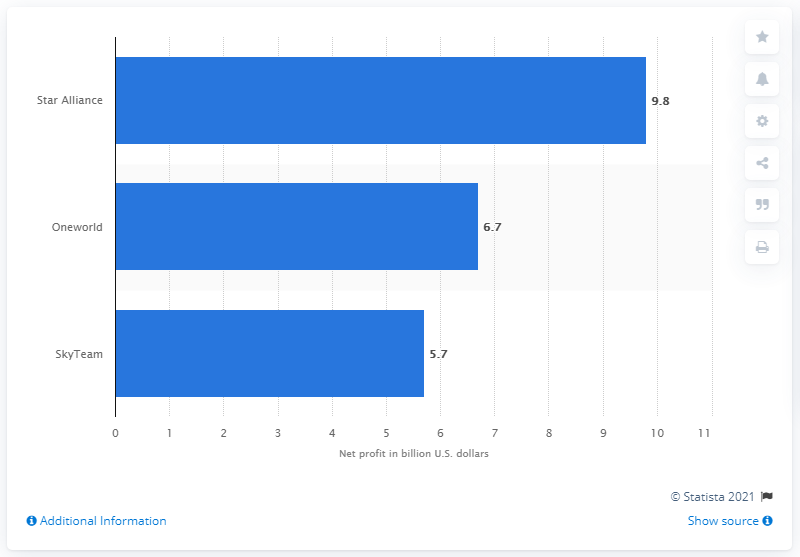Identify some key points in this picture. In 2017, Oneworld was the airline that had the largest market share of total revenue passenger kilometers, accounting for almost 40 percent of the total kilometers flown. In 2017, the net profits of Star Alliance were 9.8 billion USD. 